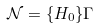Convert formula to latex. <formula><loc_0><loc_0><loc_500><loc_500>\mathcal { N } = \{ H _ { 0 } \} \Gamma</formula> 